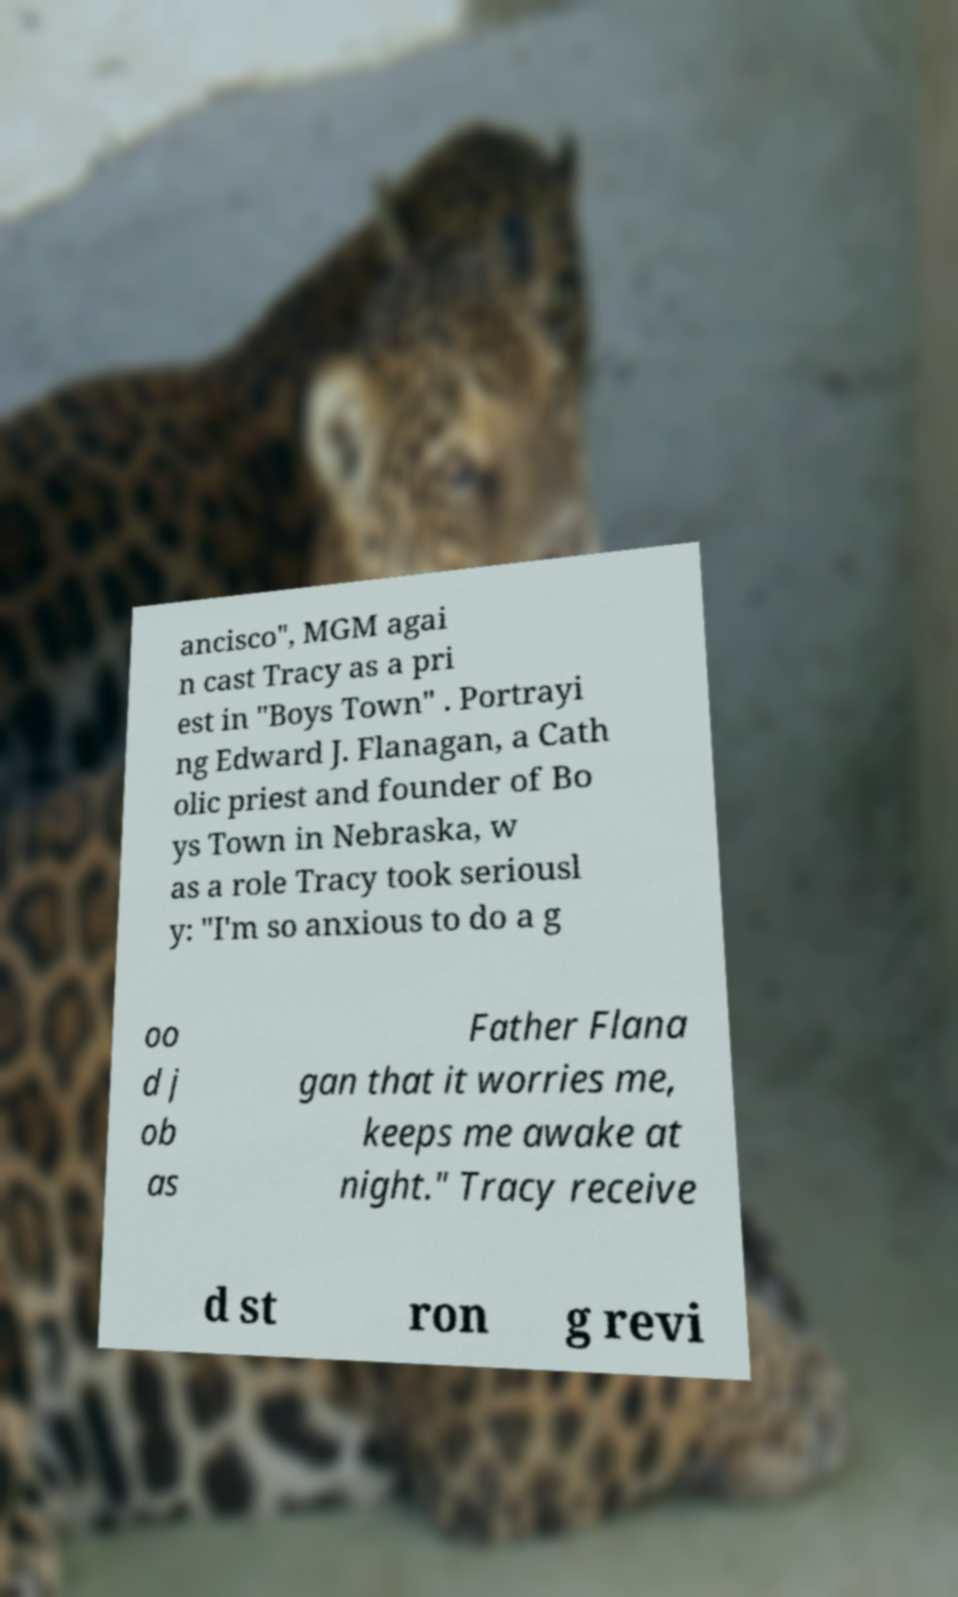Please read and relay the text visible in this image. What does it say? ancisco", MGM agai n cast Tracy as a pri est in "Boys Town" . Portrayi ng Edward J. Flanagan, a Cath olic priest and founder of Bo ys Town in Nebraska, w as a role Tracy took seriousl y: "I'm so anxious to do a g oo d j ob as Father Flana gan that it worries me, keeps me awake at night." Tracy receive d st ron g revi 